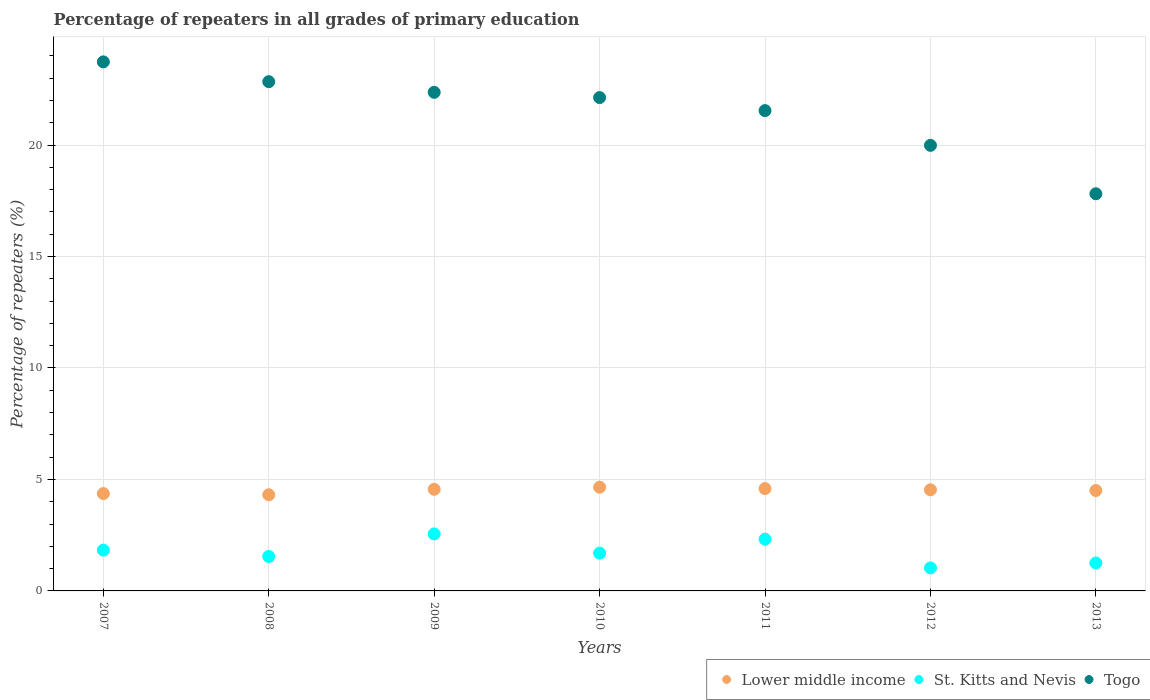How many different coloured dotlines are there?
Give a very brief answer. 3. What is the percentage of repeaters in Togo in 2007?
Ensure brevity in your answer.  23.73. Across all years, what is the maximum percentage of repeaters in Lower middle income?
Ensure brevity in your answer.  4.65. Across all years, what is the minimum percentage of repeaters in Togo?
Your response must be concise. 17.81. In which year was the percentage of repeaters in Togo minimum?
Give a very brief answer. 2013. What is the total percentage of repeaters in Togo in the graph?
Your answer should be very brief. 150.41. What is the difference between the percentage of repeaters in Lower middle income in 2009 and that in 2012?
Offer a very short reply. 0.02. What is the difference between the percentage of repeaters in St. Kitts and Nevis in 2011 and the percentage of repeaters in Lower middle income in 2010?
Keep it short and to the point. -2.33. What is the average percentage of repeaters in Togo per year?
Provide a short and direct response. 21.49. In the year 2013, what is the difference between the percentage of repeaters in Togo and percentage of repeaters in Lower middle income?
Offer a very short reply. 13.31. What is the ratio of the percentage of repeaters in Lower middle income in 2007 to that in 2010?
Provide a short and direct response. 0.94. What is the difference between the highest and the second highest percentage of repeaters in Lower middle income?
Ensure brevity in your answer.  0.06. What is the difference between the highest and the lowest percentage of repeaters in St. Kitts and Nevis?
Your answer should be compact. 1.53. In how many years, is the percentage of repeaters in Togo greater than the average percentage of repeaters in Togo taken over all years?
Your response must be concise. 5. Does the percentage of repeaters in Lower middle income monotonically increase over the years?
Make the answer very short. No. Is the percentage of repeaters in Lower middle income strictly greater than the percentage of repeaters in St. Kitts and Nevis over the years?
Ensure brevity in your answer.  Yes. Does the graph contain grids?
Keep it short and to the point. Yes. Where does the legend appear in the graph?
Offer a terse response. Bottom right. How many legend labels are there?
Offer a terse response. 3. What is the title of the graph?
Keep it short and to the point. Percentage of repeaters in all grades of primary education. What is the label or title of the Y-axis?
Provide a short and direct response. Percentage of repeaters (%). What is the Percentage of repeaters (%) in Lower middle income in 2007?
Your response must be concise. 4.37. What is the Percentage of repeaters (%) in St. Kitts and Nevis in 2007?
Your response must be concise. 1.83. What is the Percentage of repeaters (%) in Togo in 2007?
Give a very brief answer. 23.73. What is the Percentage of repeaters (%) in Lower middle income in 2008?
Offer a very short reply. 4.31. What is the Percentage of repeaters (%) of St. Kitts and Nevis in 2008?
Give a very brief answer. 1.54. What is the Percentage of repeaters (%) of Togo in 2008?
Keep it short and to the point. 22.84. What is the Percentage of repeaters (%) of Lower middle income in 2009?
Your answer should be compact. 4.56. What is the Percentage of repeaters (%) in St. Kitts and Nevis in 2009?
Keep it short and to the point. 2.56. What is the Percentage of repeaters (%) of Togo in 2009?
Ensure brevity in your answer.  22.36. What is the Percentage of repeaters (%) in Lower middle income in 2010?
Ensure brevity in your answer.  4.65. What is the Percentage of repeaters (%) of St. Kitts and Nevis in 2010?
Your answer should be compact. 1.69. What is the Percentage of repeaters (%) of Togo in 2010?
Your answer should be compact. 22.13. What is the Percentage of repeaters (%) of Lower middle income in 2011?
Provide a short and direct response. 4.59. What is the Percentage of repeaters (%) of St. Kitts and Nevis in 2011?
Provide a short and direct response. 2.32. What is the Percentage of repeaters (%) in Togo in 2011?
Give a very brief answer. 21.54. What is the Percentage of repeaters (%) of Lower middle income in 2012?
Your response must be concise. 4.54. What is the Percentage of repeaters (%) of St. Kitts and Nevis in 2012?
Keep it short and to the point. 1.03. What is the Percentage of repeaters (%) in Togo in 2012?
Offer a terse response. 19.99. What is the Percentage of repeaters (%) of Lower middle income in 2013?
Your answer should be compact. 4.5. What is the Percentage of repeaters (%) in St. Kitts and Nevis in 2013?
Offer a terse response. 1.25. What is the Percentage of repeaters (%) of Togo in 2013?
Provide a short and direct response. 17.81. Across all years, what is the maximum Percentage of repeaters (%) of Lower middle income?
Provide a short and direct response. 4.65. Across all years, what is the maximum Percentage of repeaters (%) of St. Kitts and Nevis?
Your answer should be very brief. 2.56. Across all years, what is the maximum Percentage of repeaters (%) of Togo?
Give a very brief answer. 23.73. Across all years, what is the minimum Percentage of repeaters (%) in Lower middle income?
Your answer should be compact. 4.31. Across all years, what is the minimum Percentage of repeaters (%) of St. Kitts and Nevis?
Your response must be concise. 1.03. Across all years, what is the minimum Percentage of repeaters (%) in Togo?
Keep it short and to the point. 17.81. What is the total Percentage of repeaters (%) in Lower middle income in the graph?
Your response must be concise. 31.52. What is the total Percentage of repeaters (%) of St. Kitts and Nevis in the graph?
Provide a succinct answer. 12.23. What is the total Percentage of repeaters (%) in Togo in the graph?
Keep it short and to the point. 150.41. What is the difference between the Percentage of repeaters (%) of Lower middle income in 2007 and that in 2008?
Provide a short and direct response. 0.05. What is the difference between the Percentage of repeaters (%) of St. Kitts and Nevis in 2007 and that in 2008?
Your response must be concise. 0.29. What is the difference between the Percentage of repeaters (%) of Togo in 2007 and that in 2008?
Make the answer very short. 0.89. What is the difference between the Percentage of repeaters (%) in Lower middle income in 2007 and that in 2009?
Ensure brevity in your answer.  -0.19. What is the difference between the Percentage of repeaters (%) of St. Kitts and Nevis in 2007 and that in 2009?
Offer a very short reply. -0.73. What is the difference between the Percentage of repeaters (%) in Togo in 2007 and that in 2009?
Your answer should be very brief. 1.37. What is the difference between the Percentage of repeaters (%) of Lower middle income in 2007 and that in 2010?
Provide a short and direct response. -0.29. What is the difference between the Percentage of repeaters (%) in St. Kitts and Nevis in 2007 and that in 2010?
Provide a succinct answer. 0.14. What is the difference between the Percentage of repeaters (%) of Togo in 2007 and that in 2010?
Your answer should be very brief. 1.6. What is the difference between the Percentage of repeaters (%) in Lower middle income in 2007 and that in 2011?
Give a very brief answer. -0.22. What is the difference between the Percentage of repeaters (%) in St. Kitts and Nevis in 2007 and that in 2011?
Ensure brevity in your answer.  -0.49. What is the difference between the Percentage of repeaters (%) of Togo in 2007 and that in 2011?
Provide a short and direct response. 2.19. What is the difference between the Percentage of repeaters (%) in Lower middle income in 2007 and that in 2012?
Provide a succinct answer. -0.17. What is the difference between the Percentage of repeaters (%) in St. Kitts and Nevis in 2007 and that in 2012?
Your answer should be very brief. 0.8. What is the difference between the Percentage of repeaters (%) of Togo in 2007 and that in 2012?
Make the answer very short. 3.74. What is the difference between the Percentage of repeaters (%) of Lower middle income in 2007 and that in 2013?
Offer a very short reply. -0.14. What is the difference between the Percentage of repeaters (%) of St. Kitts and Nevis in 2007 and that in 2013?
Keep it short and to the point. 0.58. What is the difference between the Percentage of repeaters (%) of Togo in 2007 and that in 2013?
Offer a terse response. 5.92. What is the difference between the Percentage of repeaters (%) of Lower middle income in 2008 and that in 2009?
Keep it short and to the point. -0.24. What is the difference between the Percentage of repeaters (%) of St. Kitts and Nevis in 2008 and that in 2009?
Offer a very short reply. -1.01. What is the difference between the Percentage of repeaters (%) in Togo in 2008 and that in 2009?
Provide a short and direct response. 0.48. What is the difference between the Percentage of repeaters (%) of Lower middle income in 2008 and that in 2010?
Your answer should be very brief. -0.34. What is the difference between the Percentage of repeaters (%) in St. Kitts and Nevis in 2008 and that in 2010?
Your response must be concise. -0.15. What is the difference between the Percentage of repeaters (%) in Togo in 2008 and that in 2010?
Keep it short and to the point. 0.71. What is the difference between the Percentage of repeaters (%) of Lower middle income in 2008 and that in 2011?
Make the answer very short. -0.28. What is the difference between the Percentage of repeaters (%) in St. Kitts and Nevis in 2008 and that in 2011?
Make the answer very short. -0.77. What is the difference between the Percentage of repeaters (%) in Togo in 2008 and that in 2011?
Make the answer very short. 1.3. What is the difference between the Percentage of repeaters (%) of Lower middle income in 2008 and that in 2012?
Offer a terse response. -0.22. What is the difference between the Percentage of repeaters (%) in St. Kitts and Nevis in 2008 and that in 2012?
Keep it short and to the point. 0.51. What is the difference between the Percentage of repeaters (%) of Togo in 2008 and that in 2012?
Give a very brief answer. 2.86. What is the difference between the Percentage of repeaters (%) of Lower middle income in 2008 and that in 2013?
Make the answer very short. -0.19. What is the difference between the Percentage of repeaters (%) of St. Kitts and Nevis in 2008 and that in 2013?
Keep it short and to the point. 0.29. What is the difference between the Percentage of repeaters (%) in Togo in 2008 and that in 2013?
Provide a short and direct response. 5.03. What is the difference between the Percentage of repeaters (%) of Lower middle income in 2009 and that in 2010?
Your answer should be very brief. -0.1. What is the difference between the Percentage of repeaters (%) of St. Kitts and Nevis in 2009 and that in 2010?
Provide a short and direct response. 0.86. What is the difference between the Percentage of repeaters (%) of Togo in 2009 and that in 2010?
Provide a succinct answer. 0.24. What is the difference between the Percentage of repeaters (%) of Lower middle income in 2009 and that in 2011?
Offer a terse response. -0.03. What is the difference between the Percentage of repeaters (%) of St. Kitts and Nevis in 2009 and that in 2011?
Provide a short and direct response. 0.24. What is the difference between the Percentage of repeaters (%) of Togo in 2009 and that in 2011?
Offer a terse response. 0.82. What is the difference between the Percentage of repeaters (%) in Lower middle income in 2009 and that in 2012?
Your answer should be very brief. 0.02. What is the difference between the Percentage of repeaters (%) of St. Kitts and Nevis in 2009 and that in 2012?
Offer a very short reply. 1.53. What is the difference between the Percentage of repeaters (%) of Togo in 2009 and that in 2012?
Provide a succinct answer. 2.38. What is the difference between the Percentage of repeaters (%) in Lower middle income in 2009 and that in 2013?
Offer a terse response. 0.06. What is the difference between the Percentage of repeaters (%) of St. Kitts and Nevis in 2009 and that in 2013?
Give a very brief answer. 1.31. What is the difference between the Percentage of repeaters (%) in Togo in 2009 and that in 2013?
Offer a very short reply. 4.55. What is the difference between the Percentage of repeaters (%) in Lower middle income in 2010 and that in 2011?
Ensure brevity in your answer.  0.06. What is the difference between the Percentage of repeaters (%) of St. Kitts and Nevis in 2010 and that in 2011?
Give a very brief answer. -0.62. What is the difference between the Percentage of repeaters (%) in Togo in 2010 and that in 2011?
Offer a very short reply. 0.58. What is the difference between the Percentage of repeaters (%) of Lower middle income in 2010 and that in 2012?
Provide a succinct answer. 0.12. What is the difference between the Percentage of repeaters (%) in St. Kitts and Nevis in 2010 and that in 2012?
Keep it short and to the point. 0.66. What is the difference between the Percentage of repeaters (%) of Togo in 2010 and that in 2012?
Give a very brief answer. 2.14. What is the difference between the Percentage of repeaters (%) in Lower middle income in 2010 and that in 2013?
Your answer should be compact. 0.15. What is the difference between the Percentage of repeaters (%) of St. Kitts and Nevis in 2010 and that in 2013?
Offer a terse response. 0.44. What is the difference between the Percentage of repeaters (%) of Togo in 2010 and that in 2013?
Your answer should be compact. 4.31. What is the difference between the Percentage of repeaters (%) of Lower middle income in 2011 and that in 2012?
Provide a short and direct response. 0.05. What is the difference between the Percentage of repeaters (%) of St. Kitts and Nevis in 2011 and that in 2012?
Your answer should be compact. 1.29. What is the difference between the Percentage of repeaters (%) of Togo in 2011 and that in 2012?
Provide a succinct answer. 1.56. What is the difference between the Percentage of repeaters (%) in Lower middle income in 2011 and that in 2013?
Your answer should be very brief. 0.09. What is the difference between the Percentage of repeaters (%) in St. Kitts and Nevis in 2011 and that in 2013?
Ensure brevity in your answer.  1.07. What is the difference between the Percentage of repeaters (%) in Togo in 2011 and that in 2013?
Ensure brevity in your answer.  3.73. What is the difference between the Percentage of repeaters (%) of Lower middle income in 2012 and that in 2013?
Keep it short and to the point. 0.03. What is the difference between the Percentage of repeaters (%) in St. Kitts and Nevis in 2012 and that in 2013?
Your answer should be compact. -0.22. What is the difference between the Percentage of repeaters (%) in Togo in 2012 and that in 2013?
Make the answer very short. 2.17. What is the difference between the Percentage of repeaters (%) in Lower middle income in 2007 and the Percentage of repeaters (%) in St. Kitts and Nevis in 2008?
Make the answer very short. 2.82. What is the difference between the Percentage of repeaters (%) in Lower middle income in 2007 and the Percentage of repeaters (%) in Togo in 2008?
Provide a short and direct response. -18.48. What is the difference between the Percentage of repeaters (%) of St. Kitts and Nevis in 2007 and the Percentage of repeaters (%) of Togo in 2008?
Your response must be concise. -21.01. What is the difference between the Percentage of repeaters (%) in Lower middle income in 2007 and the Percentage of repeaters (%) in St. Kitts and Nevis in 2009?
Ensure brevity in your answer.  1.81. What is the difference between the Percentage of repeaters (%) in Lower middle income in 2007 and the Percentage of repeaters (%) in Togo in 2009?
Provide a short and direct response. -18. What is the difference between the Percentage of repeaters (%) in St. Kitts and Nevis in 2007 and the Percentage of repeaters (%) in Togo in 2009?
Offer a terse response. -20.53. What is the difference between the Percentage of repeaters (%) of Lower middle income in 2007 and the Percentage of repeaters (%) of St. Kitts and Nevis in 2010?
Your response must be concise. 2.67. What is the difference between the Percentage of repeaters (%) in Lower middle income in 2007 and the Percentage of repeaters (%) in Togo in 2010?
Offer a terse response. -17.76. What is the difference between the Percentage of repeaters (%) in St. Kitts and Nevis in 2007 and the Percentage of repeaters (%) in Togo in 2010?
Provide a short and direct response. -20.3. What is the difference between the Percentage of repeaters (%) of Lower middle income in 2007 and the Percentage of repeaters (%) of St. Kitts and Nevis in 2011?
Provide a succinct answer. 2.05. What is the difference between the Percentage of repeaters (%) of Lower middle income in 2007 and the Percentage of repeaters (%) of Togo in 2011?
Your response must be concise. -17.18. What is the difference between the Percentage of repeaters (%) in St. Kitts and Nevis in 2007 and the Percentage of repeaters (%) in Togo in 2011?
Ensure brevity in your answer.  -19.71. What is the difference between the Percentage of repeaters (%) of Lower middle income in 2007 and the Percentage of repeaters (%) of St. Kitts and Nevis in 2012?
Your answer should be compact. 3.33. What is the difference between the Percentage of repeaters (%) of Lower middle income in 2007 and the Percentage of repeaters (%) of Togo in 2012?
Provide a succinct answer. -15.62. What is the difference between the Percentage of repeaters (%) of St. Kitts and Nevis in 2007 and the Percentage of repeaters (%) of Togo in 2012?
Your answer should be compact. -18.16. What is the difference between the Percentage of repeaters (%) in Lower middle income in 2007 and the Percentage of repeaters (%) in St. Kitts and Nevis in 2013?
Provide a short and direct response. 3.11. What is the difference between the Percentage of repeaters (%) in Lower middle income in 2007 and the Percentage of repeaters (%) in Togo in 2013?
Provide a short and direct response. -13.45. What is the difference between the Percentage of repeaters (%) in St. Kitts and Nevis in 2007 and the Percentage of repeaters (%) in Togo in 2013?
Your answer should be compact. -15.98. What is the difference between the Percentage of repeaters (%) of Lower middle income in 2008 and the Percentage of repeaters (%) of St. Kitts and Nevis in 2009?
Your response must be concise. 1.76. What is the difference between the Percentage of repeaters (%) in Lower middle income in 2008 and the Percentage of repeaters (%) in Togo in 2009?
Your answer should be compact. -18.05. What is the difference between the Percentage of repeaters (%) in St. Kitts and Nevis in 2008 and the Percentage of repeaters (%) in Togo in 2009?
Offer a very short reply. -20.82. What is the difference between the Percentage of repeaters (%) in Lower middle income in 2008 and the Percentage of repeaters (%) in St. Kitts and Nevis in 2010?
Your answer should be compact. 2.62. What is the difference between the Percentage of repeaters (%) of Lower middle income in 2008 and the Percentage of repeaters (%) of Togo in 2010?
Make the answer very short. -17.82. What is the difference between the Percentage of repeaters (%) of St. Kitts and Nevis in 2008 and the Percentage of repeaters (%) of Togo in 2010?
Offer a terse response. -20.58. What is the difference between the Percentage of repeaters (%) of Lower middle income in 2008 and the Percentage of repeaters (%) of St. Kitts and Nevis in 2011?
Your answer should be very brief. 1.99. What is the difference between the Percentage of repeaters (%) of Lower middle income in 2008 and the Percentage of repeaters (%) of Togo in 2011?
Keep it short and to the point. -17.23. What is the difference between the Percentage of repeaters (%) of St. Kitts and Nevis in 2008 and the Percentage of repeaters (%) of Togo in 2011?
Make the answer very short. -20. What is the difference between the Percentage of repeaters (%) in Lower middle income in 2008 and the Percentage of repeaters (%) in St. Kitts and Nevis in 2012?
Give a very brief answer. 3.28. What is the difference between the Percentage of repeaters (%) in Lower middle income in 2008 and the Percentage of repeaters (%) in Togo in 2012?
Your response must be concise. -15.67. What is the difference between the Percentage of repeaters (%) of St. Kitts and Nevis in 2008 and the Percentage of repeaters (%) of Togo in 2012?
Offer a very short reply. -18.44. What is the difference between the Percentage of repeaters (%) in Lower middle income in 2008 and the Percentage of repeaters (%) in St. Kitts and Nevis in 2013?
Provide a succinct answer. 3.06. What is the difference between the Percentage of repeaters (%) of Lower middle income in 2008 and the Percentage of repeaters (%) of Togo in 2013?
Provide a succinct answer. -13.5. What is the difference between the Percentage of repeaters (%) in St. Kitts and Nevis in 2008 and the Percentage of repeaters (%) in Togo in 2013?
Give a very brief answer. -16.27. What is the difference between the Percentage of repeaters (%) in Lower middle income in 2009 and the Percentage of repeaters (%) in St. Kitts and Nevis in 2010?
Offer a terse response. 2.86. What is the difference between the Percentage of repeaters (%) in Lower middle income in 2009 and the Percentage of repeaters (%) in Togo in 2010?
Your response must be concise. -17.57. What is the difference between the Percentage of repeaters (%) of St. Kitts and Nevis in 2009 and the Percentage of repeaters (%) of Togo in 2010?
Offer a terse response. -19.57. What is the difference between the Percentage of repeaters (%) of Lower middle income in 2009 and the Percentage of repeaters (%) of St. Kitts and Nevis in 2011?
Make the answer very short. 2.24. What is the difference between the Percentage of repeaters (%) in Lower middle income in 2009 and the Percentage of repeaters (%) in Togo in 2011?
Give a very brief answer. -16.99. What is the difference between the Percentage of repeaters (%) of St. Kitts and Nevis in 2009 and the Percentage of repeaters (%) of Togo in 2011?
Your answer should be compact. -18.99. What is the difference between the Percentage of repeaters (%) of Lower middle income in 2009 and the Percentage of repeaters (%) of St. Kitts and Nevis in 2012?
Provide a succinct answer. 3.53. What is the difference between the Percentage of repeaters (%) in Lower middle income in 2009 and the Percentage of repeaters (%) in Togo in 2012?
Ensure brevity in your answer.  -15.43. What is the difference between the Percentage of repeaters (%) in St. Kitts and Nevis in 2009 and the Percentage of repeaters (%) in Togo in 2012?
Provide a short and direct response. -17.43. What is the difference between the Percentage of repeaters (%) of Lower middle income in 2009 and the Percentage of repeaters (%) of St. Kitts and Nevis in 2013?
Offer a terse response. 3.31. What is the difference between the Percentage of repeaters (%) of Lower middle income in 2009 and the Percentage of repeaters (%) of Togo in 2013?
Offer a terse response. -13.26. What is the difference between the Percentage of repeaters (%) of St. Kitts and Nevis in 2009 and the Percentage of repeaters (%) of Togo in 2013?
Ensure brevity in your answer.  -15.26. What is the difference between the Percentage of repeaters (%) of Lower middle income in 2010 and the Percentage of repeaters (%) of St. Kitts and Nevis in 2011?
Offer a very short reply. 2.33. What is the difference between the Percentage of repeaters (%) of Lower middle income in 2010 and the Percentage of repeaters (%) of Togo in 2011?
Your response must be concise. -16.89. What is the difference between the Percentage of repeaters (%) of St. Kitts and Nevis in 2010 and the Percentage of repeaters (%) of Togo in 2011?
Keep it short and to the point. -19.85. What is the difference between the Percentage of repeaters (%) of Lower middle income in 2010 and the Percentage of repeaters (%) of St. Kitts and Nevis in 2012?
Your answer should be compact. 3.62. What is the difference between the Percentage of repeaters (%) of Lower middle income in 2010 and the Percentage of repeaters (%) of Togo in 2012?
Provide a succinct answer. -15.33. What is the difference between the Percentage of repeaters (%) in St. Kitts and Nevis in 2010 and the Percentage of repeaters (%) in Togo in 2012?
Provide a short and direct response. -18.29. What is the difference between the Percentage of repeaters (%) of Lower middle income in 2010 and the Percentage of repeaters (%) of St. Kitts and Nevis in 2013?
Keep it short and to the point. 3.4. What is the difference between the Percentage of repeaters (%) in Lower middle income in 2010 and the Percentage of repeaters (%) in Togo in 2013?
Keep it short and to the point. -13.16. What is the difference between the Percentage of repeaters (%) of St. Kitts and Nevis in 2010 and the Percentage of repeaters (%) of Togo in 2013?
Your response must be concise. -16.12. What is the difference between the Percentage of repeaters (%) of Lower middle income in 2011 and the Percentage of repeaters (%) of St. Kitts and Nevis in 2012?
Offer a terse response. 3.56. What is the difference between the Percentage of repeaters (%) in Lower middle income in 2011 and the Percentage of repeaters (%) in Togo in 2012?
Offer a very short reply. -15.4. What is the difference between the Percentage of repeaters (%) in St. Kitts and Nevis in 2011 and the Percentage of repeaters (%) in Togo in 2012?
Your answer should be compact. -17.67. What is the difference between the Percentage of repeaters (%) in Lower middle income in 2011 and the Percentage of repeaters (%) in St. Kitts and Nevis in 2013?
Make the answer very short. 3.34. What is the difference between the Percentage of repeaters (%) of Lower middle income in 2011 and the Percentage of repeaters (%) of Togo in 2013?
Your response must be concise. -13.22. What is the difference between the Percentage of repeaters (%) in St. Kitts and Nevis in 2011 and the Percentage of repeaters (%) in Togo in 2013?
Ensure brevity in your answer.  -15.5. What is the difference between the Percentage of repeaters (%) in Lower middle income in 2012 and the Percentage of repeaters (%) in St. Kitts and Nevis in 2013?
Keep it short and to the point. 3.28. What is the difference between the Percentage of repeaters (%) of Lower middle income in 2012 and the Percentage of repeaters (%) of Togo in 2013?
Keep it short and to the point. -13.28. What is the difference between the Percentage of repeaters (%) of St. Kitts and Nevis in 2012 and the Percentage of repeaters (%) of Togo in 2013?
Your response must be concise. -16.78. What is the average Percentage of repeaters (%) in Lower middle income per year?
Ensure brevity in your answer.  4.5. What is the average Percentage of repeaters (%) in St. Kitts and Nevis per year?
Offer a very short reply. 1.75. What is the average Percentage of repeaters (%) of Togo per year?
Your response must be concise. 21.49. In the year 2007, what is the difference between the Percentage of repeaters (%) in Lower middle income and Percentage of repeaters (%) in St. Kitts and Nevis?
Offer a terse response. 2.54. In the year 2007, what is the difference between the Percentage of repeaters (%) in Lower middle income and Percentage of repeaters (%) in Togo?
Your response must be concise. -19.36. In the year 2007, what is the difference between the Percentage of repeaters (%) in St. Kitts and Nevis and Percentage of repeaters (%) in Togo?
Provide a short and direct response. -21.9. In the year 2008, what is the difference between the Percentage of repeaters (%) in Lower middle income and Percentage of repeaters (%) in St. Kitts and Nevis?
Keep it short and to the point. 2.77. In the year 2008, what is the difference between the Percentage of repeaters (%) in Lower middle income and Percentage of repeaters (%) in Togo?
Offer a terse response. -18.53. In the year 2008, what is the difference between the Percentage of repeaters (%) in St. Kitts and Nevis and Percentage of repeaters (%) in Togo?
Your answer should be compact. -21.3. In the year 2009, what is the difference between the Percentage of repeaters (%) of Lower middle income and Percentage of repeaters (%) of St. Kitts and Nevis?
Your response must be concise. 2. In the year 2009, what is the difference between the Percentage of repeaters (%) in Lower middle income and Percentage of repeaters (%) in Togo?
Keep it short and to the point. -17.81. In the year 2009, what is the difference between the Percentage of repeaters (%) in St. Kitts and Nevis and Percentage of repeaters (%) in Togo?
Offer a terse response. -19.81. In the year 2010, what is the difference between the Percentage of repeaters (%) in Lower middle income and Percentage of repeaters (%) in St. Kitts and Nevis?
Your response must be concise. 2.96. In the year 2010, what is the difference between the Percentage of repeaters (%) of Lower middle income and Percentage of repeaters (%) of Togo?
Your answer should be compact. -17.48. In the year 2010, what is the difference between the Percentage of repeaters (%) in St. Kitts and Nevis and Percentage of repeaters (%) in Togo?
Make the answer very short. -20.43. In the year 2011, what is the difference between the Percentage of repeaters (%) of Lower middle income and Percentage of repeaters (%) of St. Kitts and Nevis?
Provide a short and direct response. 2.27. In the year 2011, what is the difference between the Percentage of repeaters (%) of Lower middle income and Percentage of repeaters (%) of Togo?
Your response must be concise. -16.95. In the year 2011, what is the difference between the Percentage of repeaters (%) of St. Kitts and Nevis and Percentage of repeaters (%) of Togo?
Make the answer very short. -19.23. In the year 2012, what is the difference between the Percentage of repeaters (%) in Lower middle income and Percentage of repeaters (%) in St. Kitts and Nevis?
Give a very brief answer. 3.5. In the year 2012, what is the difference between the Percentage of repeaters (%) of Lower middle income and Percentage of repeaters (%) of Togo?
Your answer should be very brief. -15.45. In the year 2012, what is the difference between the Percentage of repeaters (%) in St. Kitts and Nevis and Percentage of repeaters (%) in Togo?
Ensure brevity in your answer.  -18.95. In the year 2013, what is the difference between the Percentage of repeaters (%) of Lower middle income and Percentage of repeaters (%) of St. Kitts and Nevis?
Provide a short and direct response. 3.25. In the year 2013, what is the difference between the Percentage of repeaters (%) of Lower middle income and Percentage of repeaters (%) of Togo?
Keep it short and to the point. -13.31. In the year 2013, what is the difference between the Percentage of repeaters (%) in St. Kitts and Nevis and Percentage of repeaters (%) in Togo?
Provide a short and direct response. -16.56. What is the ratio of the Percentage of repeaters (%) in Lower middle income in 2007 to that in 2008?
Make the answer very short. 1.01. What is the ratio of the Percentage of repeaters (%) in St. Kitts and Nevis in 2007 to that in 2008?
Your response must be concise. 1.19. What is the ratio of the Percentage of repeaters (%) in Togo in 2007 to that in 2008?
Offer a very short reply. 1.04. What is the ratio of the Percentage of repeaters (%) of Lower middle income in 2007 to that in 2009?
Make the answer very short. 0.96. What is the ratio of the Percentage of repeaters (%) of St. Kitts and Nevis in 2007 to that in 2009?
Offer a terse response. 0.72. What is the ratio of the Percentage of repeaters (%) in Togo in 2007 to that in 2009?
Your answer should be very brief. 1.06. What is the ratio of the Percentage of repeaters (%) of Lower middle income in 2007 to that in 2010?
Your answer should be compact. 0.94. What is the ratio of the Percentage of repeaters (%) of St. Kitts and Nevis in 2007 to that in 2010?
Provide a succinct answer. 1.08. What is the ratio of the Percentage of repeaters (%) of Togo in 2007 to that in 2010?
Ensure brevity in your answer.  1.07. What is the ratio of the Percentage of repeaters (%) in Lower middle income in 2007 to that in 2011?
Offer a very short reply. 0.95. What is the ratio of the Percentage of repeaters (%) in St. Kitts and Nevis in 2007 to that in 2011?
Ensure brevity in your answer.  0.79. What is the ratio of the Percentage of repeaters (%) in Togo in 2007 to that in 2011?
Ensure brevity in your answer.  1.1. What is the ratio of the Percentage of repeaters (%) of Lower middle income in 2007 to that in 2012?
Keep it short and to the point. 0.96. What is the ratio of the Percentage of repeaters (%) of St. Kitts and Nevis in 2007 to that in 2012?
Your answer should be very brief. 1.77. What is the ratio of the Percentage of repeaters (%) in Togo in 2007 to that in 2012?
Offer a very short reply. 1.19. What is the ratio of the Percentage of repeaters (%) in Lower middle income in 2007 to that in 2013?
Offer a terse response. 0.97. What is the ratio of the Percentage of repeaters (%) in St. Kitts and Nevis in 2007 to that in 2013?
Provide a succinct answer. 1.46. What is the ratio of the Percentage of repeaters (%) of Togo in 2007 to that in 2013?
Your response must be concise. 1.33. What is the ratio of the Percentage of repeaters (%) in Lower middle income in 2008 to that in 2009?
Ensure brevity in your answer.  0.95. What is the ratio of the Percentage of repeaters (%) in St. Kitts and Nevis in 2008 to that in 2009?
Offer a very short reply. 0.6. What is the ratio of the Percentage of repeaters (%) in Togo in 2008 to that in 2009?
Make the answer very short. 1.02. What is the ratio of the Percentage of repeaters (%) in Lower middle income in 2008 to that in 2010?
Offer a terse response. 0.93. What is the ratio of the Percentage of repeaters (%) of St. Kitts and Nevis in 2008 to that in 2010?
Your answer should be compact. 0.91. What is the ratio of the Percentage of repeaters (%) of Togo in 2008 to that in 2010?
Give a very brief answer. 1.03. What is the ratio of the Percentage of repeaters (%) of Lower middle income in 2008 to that in 2011?
Keep it short and to the point. 0.94. What is the ratio of the Percentage of repeaters (%) of St. Kitts and Nevis in 2008 to that in 2011?
Ensure brevity in your answer.  0.67. What is the ratio of the Percentage of repeaters (%) of Togo in 2008 to that in 2011?
Give a very brief answer. 1.06. What is the ratio of the Percentage of repeaters (%) of Lower middle income in 2008 to that in 2012?
Keep it short and to the point. 0.95. What is the ratio of the Percentage of repeaters (%) in St. Kitts and Nevis in 2008 to that in 2012?
Your response must be concise. 1.5. What is the ratio of the Percentage of repeaters (%) of Togo in 2008 to that in 2012?
Provide a short and direct response. 1.14. What is the ratio of the Percentage of repeaters (%) of Lower middle income in 2008 to that in 2013?
Ensure brevity in your answer.  0.96. What is the ratio of the Percentage of repeaters (%) of St. Kitts and Nevis in 2008 to that in 2013?
Your answer should be very brief. 1.23. What is the ratio of the Percentage of repeaters (%) of Togo in 2008 to that in 2013?
Keep it short and to the point. 1.28. What is the ratio of the Percentage of repeaters (%) in Lower middle income in 2009 to that in 2010?
Provide a short and direct response. 0.98. What is the ratio of the Percentage of repeaters (%) in St. Kitts and Nevis in 2009 to that in 2010?
Make the answer very short. 1.51. What is the ratio of the Percentage of repeaters (%) in Togo in 2009 to that in 2010?
Provide a succinct answer. 1.01. What is the ratio of the Percentage of repeaters (%) in St. Kitts and Nevis in 2009 to that in 2011?
Offer a very short reply. 1.1. What is the ratio of the Percentage of repeaters (%) in Togo in 2009 to that in 2011?
Provide a succinct answer. 1.04. What is the ratio of the Percentage of repeaters (%) in St. Kitts and Nevis in 2009 to that in 2012?
Your response must be concise. 2.48. What is the ratio of the Percentage of repeaters (%) in Togo in 2009 to that in 2012?
Provide a succinct answer. 1.12. What is the ratio of the Percentage of repeaters (%) of Lower middle income in 2009 to that in 2013?
Provide a short and direct response. 1.01. What is the ratio of the Percentage of repeaters (%) of St. Kitts and Nevis in 2009 to that in 2013?
Offer a terse response. 2.04. What is the ratio of the Percentage of repeaters (%) in Togo in 2009 to that in 2013?
Ensure brevity in your answer.  1.26. What is the ratio of the Percentage of repeaters (%) of Lower middle income in 2010 to that in 2011?
Offer a very short reply. 1.01. What is the ratio of the Percentage of repeaters (%) in St. Kitts and Nevis in 2010 to that in 2011?
Your response must be concise. 0.73. What is the ratio of the Percentage of repeaters (%) in Togo in 2010 to that in 2011?
Your answer should be very brief. 1.03. What is the ratio of the Percentage of repeaters (%) of Lower middle income in 2010 to that in 2012?
Provide a short and direct response. 1.03. What is the ratio of the Percentage of repeaters (%) of St. Kitts and Nevis in 2010 to that in 2012?
Your answer should be very brief. 1.64. What is the ratio of the Percentage of repeaters (%) of Togo in 2010 to that in 2012?
Keep it short and to the point. 1.11. What is the ratio of the Percentage of repeaters (%) of Lower middle income in 2010 to that in 2013?
Offer a very short reply. 1.03. What is the ratio of the Percentage of repeaters (%) of St. Kitts and Nevis in 2010 to that in 2013?
Your answer should be very brief. 1.35. What is the ratio of the Percentage of repeaters (%) of Togo in 2010 to that in 2013?
Provide a succinct answer. 1.24. What is the ratio of the Percentage of repeaters (%) of Lower middle income in 2011 to that in 2012?
Give a very brief answer. 1.01. What is the ratio of the Percentage of repeaters (%) in St. Kitts and Nevis in 2011 to that in 2012?
Your response must be concise. 2.25. What is the ratio of the Percentage of repeaters (%) in Togo in 2011 to that in 2012?
Your answer should be very brief. 1.08. What is the ratio of the Percentage of repeaters (%) in Lower middle income in 2011 to that in 2013?
Your answer should be very brief. 1.02. What is the ratio of the Percentage of repeaters (%) of St. Kitts and Nevis in 2011 to that in 2013?
Your answer should be very brief. 1.85. What is the ratio of the Percentage of repeaters (%) of Togo in 2011 to that in 2013?
Provide a short and direct response. 1.21. What is the ratio of the Percentage of repeaters (%) in Lower middle income in 2012 to that in 2013?
Give a very brief answer. 1.01. What is the ratio of the Percentage of repeaters (%) in St. Kitts and Nevis in 2012 to that in 2013?
Make the answer very short. 0.82. What is the ratio of the Percentage of repeaters (%) of Togo in 2012 to that in 2013?
Your answer should be compact. 1.12. What is the difference between the highest and the second highest Percentage of repeaters (%) of Lower middle income?
Give a very brief answer. 0.06. What is the difference between the highest and the second highest Percentage of repeaters (%) in St. Kitts and Nevis?
Give a very brief answer. 0.24. What is the difference between the highest and the second highest Percentage of repeaters (%) in Togo?
Give a very brief answer. 0.89. What is the difference between the highest and the lowest Percentage of repeaters (%) in Lower middle income?
Keep it short and to the point. 0.34. What is the difference between the highest and the lowest Percentage of repeaters (%) in St. Kitts and Nevis?
Make the answer very short. 1.53. What is the difference between the highest and the lowest Percentage of repeaters (%) in Togo?
Your answer should be very brief. 5.92. 